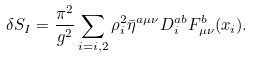Convert formula to latex. <formula><loc_0><loc_0><loc_500><loc_500>\delta S _ { I } = \frac { \pi ^ { 2 } } { g ^ { 2 } } \sum _ { i = i , 2 } \rho _ { i } ^ { 2 } \bar { \eta } ^ { a \mu \nu } D _ { i } ^ { a b } F _ { \mu \nu } ^ { b } ( x _ { i } ) .</formula> 